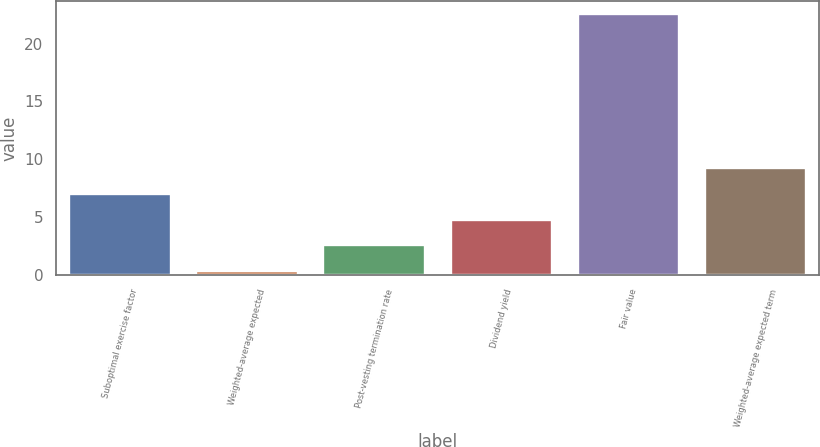Convert chart to OTSL. <chart><loc_0><loc_0><loc_500><loc_500><bar_chart><fcel>Suboptimal exercise factor<fcel>Weighted-average expected<fcel>Post-vesting termination rate<fcel>Dividend yield<fcel>Fair value<fcel>Weighted-average expected term<nl><fcel>7.01<fcel>0.35<fcel>2.57<fcel>4.79<fcel>22.54<fcel>9.23<nl></chart> 